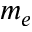Convert formula to latex. <formula><loc_0><loc_0><loc_500><loc_500>m _ { e }</formula> 